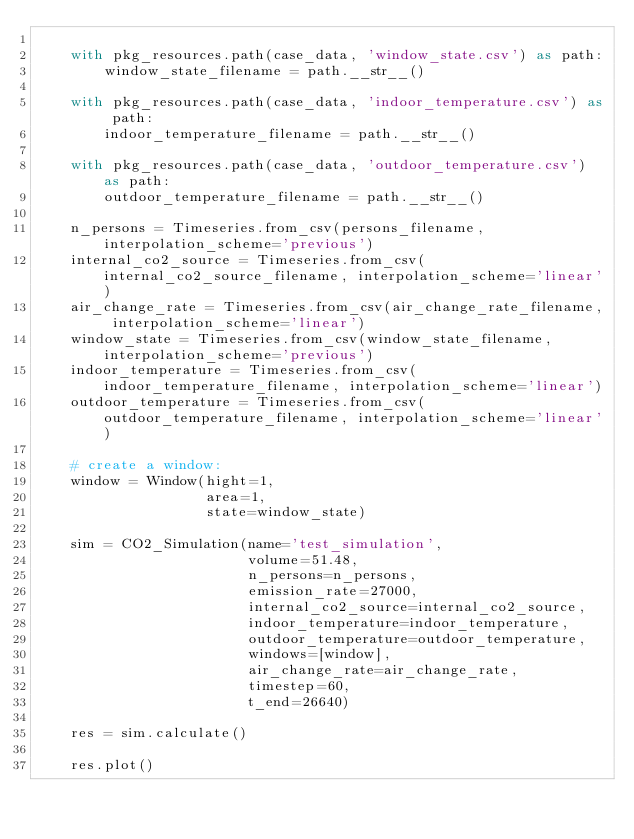Convert code to text. <code><loc_0><loc_0><loc_500><loc_500><_Python_>
    with pkg_resources.path(case_data, 'window_state.csv') as path:
        window_state_filename = path.__str__()

    with pkg_resources.path(case_data, 'indoor_temperature.csv') as path:
        indoor_temperature_filename = path.__str__()

    with pkg_resources.path(case_data, 'outdoor_temperature.csv') as path:
        outdoor_temperature_filename = path.__str__()

    n_persons = Timeseries.from_csv(persons_filename, interpolation_scheme='previous')
    internal_co2_source = Timeseries.from_csv(internal_co2_source_filename, interpolation_scheme='linear')
    air_change_rate = Timeseries.from_csv(air_change_rate_filename, interpolation_scheme='linear')
    window_state = Timeseries.from_csv(window_state_filename, interpolation_scheme='previous')
    indoor_temperature = Timeseries.from_csv(indoor_temperature_filename, interpolation_scheme='linear')
    outdoor_temperature = Timeseries.from_csv(outdoor_temperature_filename, interpolation_scheme='linear')

    # create a window:
    window = Window(hight=1,
                    area=1,
                    state=window_state)

    sim = CO2_Simulation(name='test_simulation',
                         volume=51.48,
                         n_persons=n_persons,
                         emission_rate=27000,
                         internal_co2_source=internal_co2_source,
                         indoor_temperature=indoor_temperature,
                         outdoor_temperature=outdoor_temperature,
                         windows=[window],
                         air_change_rate=air_change_rate,
                         timestep=60,
                         t_end=26640)

    res = sim.calculate()

    res.plot()
</code> 